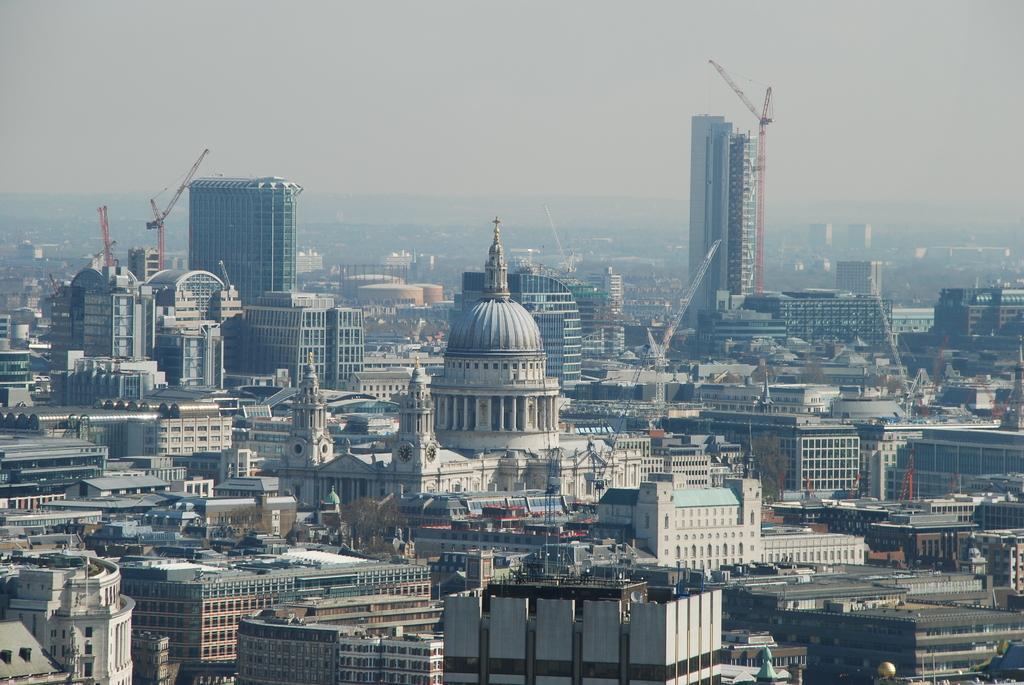Please provide a concise description of this image. This is an aerial view of the buildings which have many glass windows and we also observe two buildings which are under construction. In the background we observe fog on the buildings. 